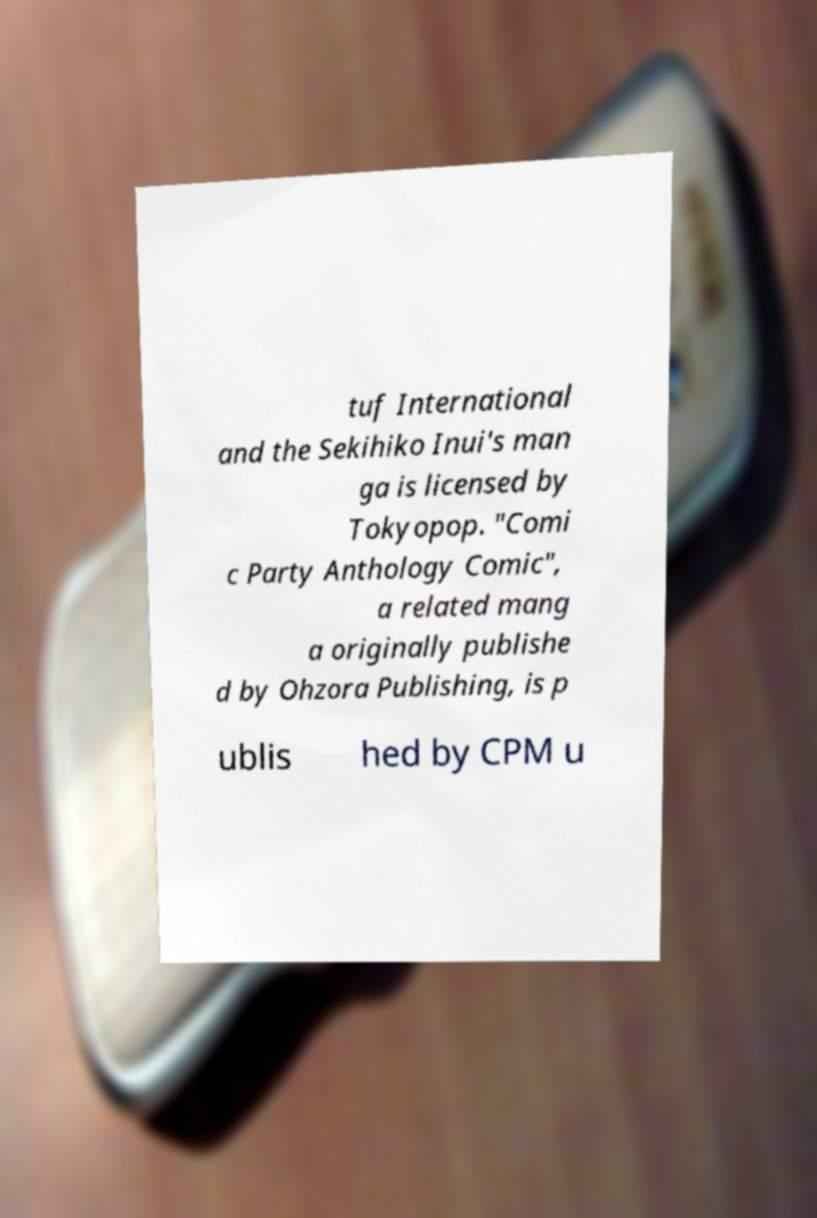Could you extract and type out the text from this image? tuf International and the Sekihiko Inui's man ga is licensed by Tokyopop. "Comi c Party Anthology Comic", a related mang a originally publishe d by Ohzora Publishing, is p ublis hed by CPM u 